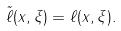Convert formula to latex. <formula><loc_0><loc_0><loc_500><loc_500>\tilde { \ell } ( x , \xi ) = \ell ( x , \xi ) .</formula> 